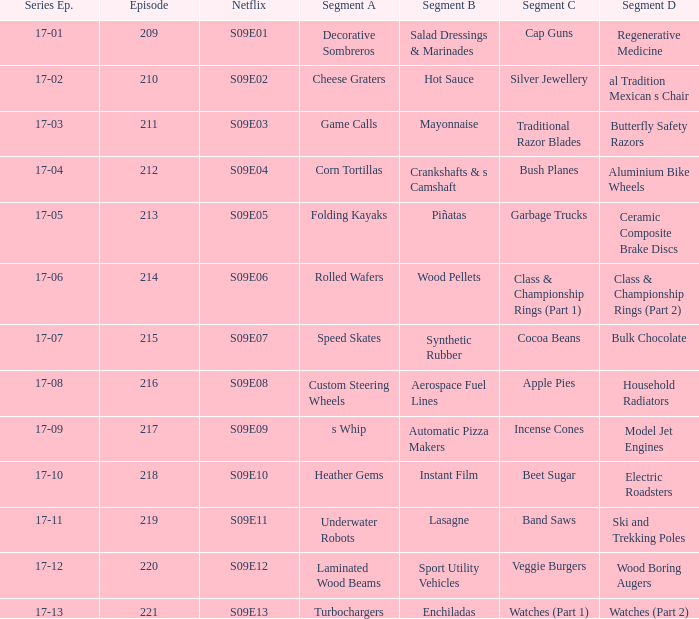What does segment a have in aerospace fuel lines segment b? Custom Steering Wheels. 